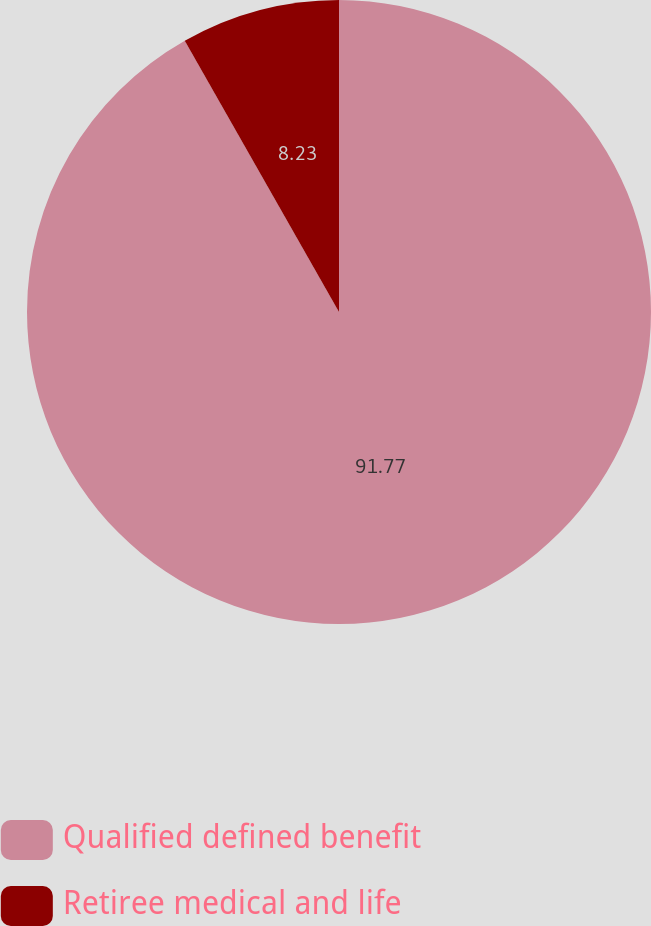Convert chart. <chart><loc_0><loc_0><loc_500><loc_500><pie_chart><fcel>Qualified defined benefit<fcel>Retiree medical and life<nl><fcel>91.77%<fcel>8.23%<nl></chart> 